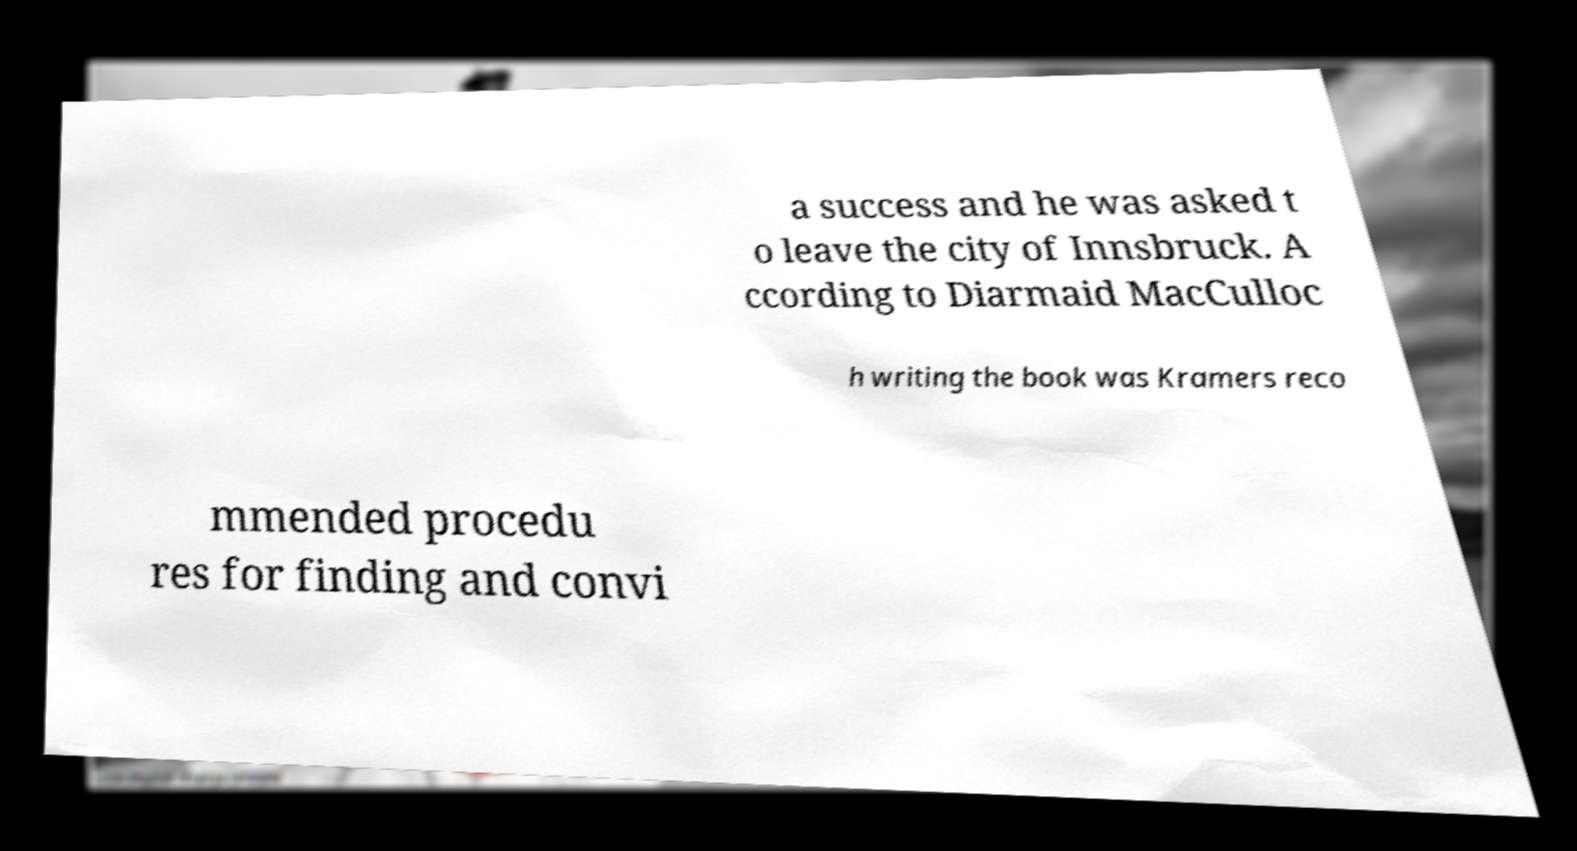I need the written content from this picture converted into text. Can you do that? a success and he was asked t o leave the city of Innsbruck. A ccording to Diarmaid MacCulloc h writing the book was Kramers reco mmended procedu res for finding and convi 